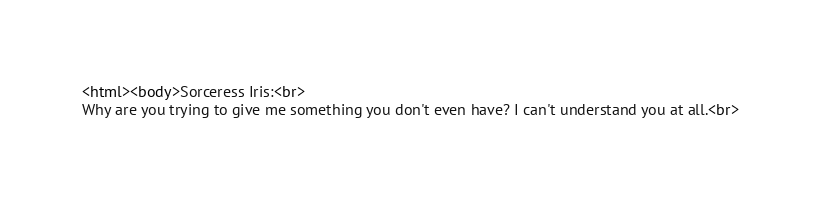Convert code to text. <code><loc_0><loc_0><loc_500><loc_500><_HTML_><html><body>Sorceress Iris:<br>
Why are you trying to give me something you don't even have? I can't understand you at all.<br></code> 